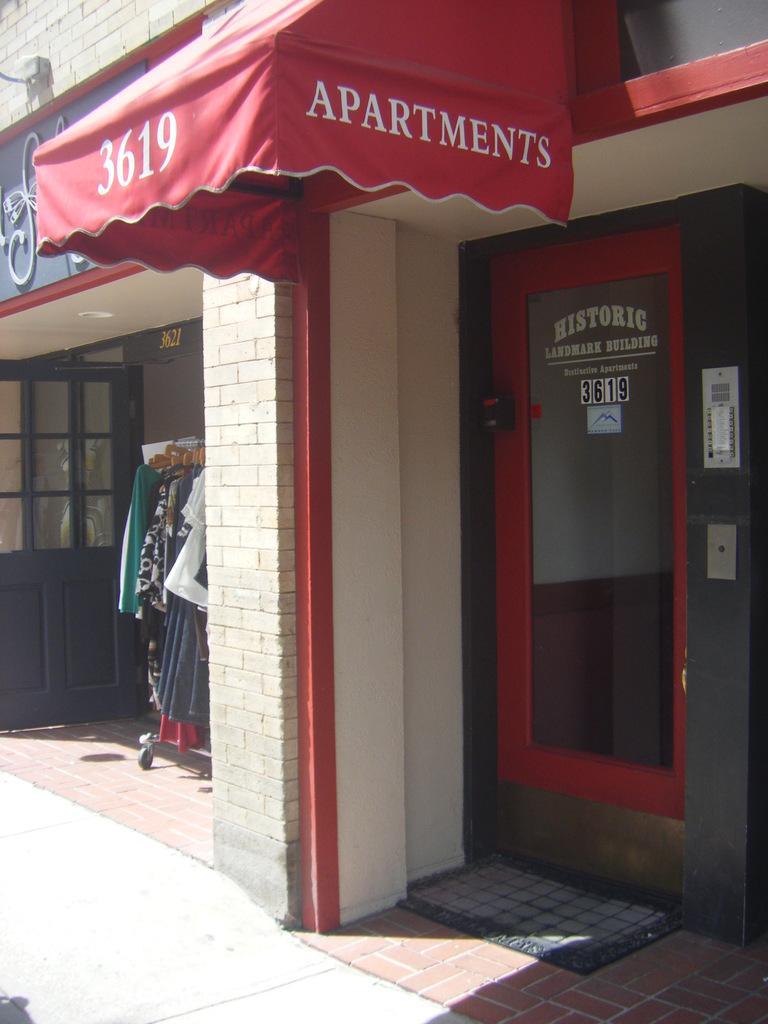How would you summarize this image in a sentence or two? In this image we can see a store with some text on it and we can also see a door, clothes and a mat. 